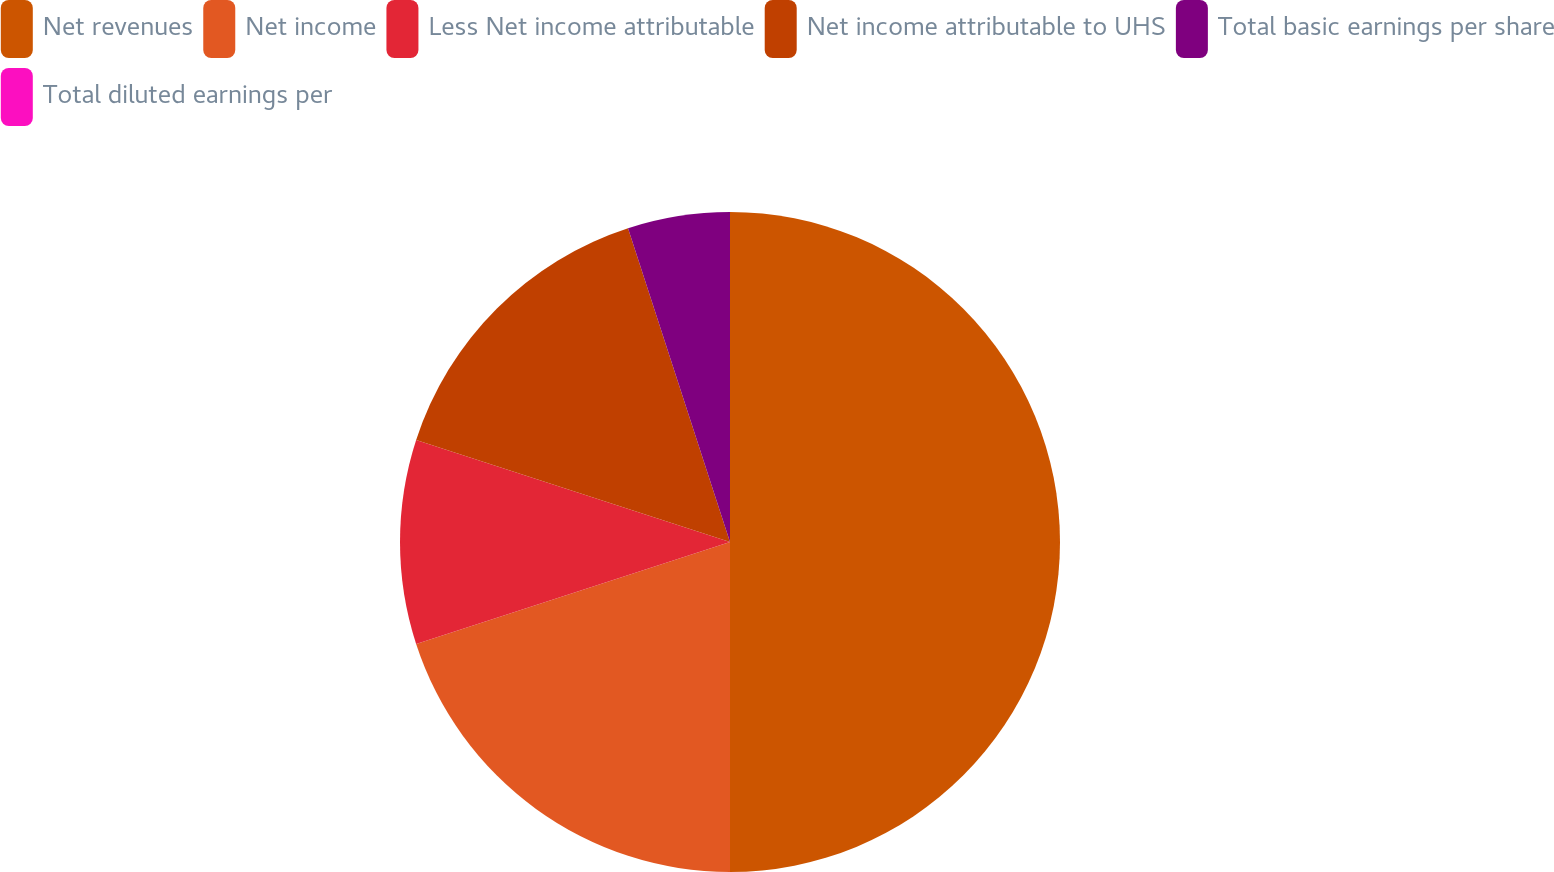<chart> <loc_0><loc_0><loc_500><loc_500><pie_chart><fcel>Net revenues<fcel>Net income<fcel>Less Net income attributable<fcel>Net income attributable to UHS<fcel>Total basic earnings per share<fcel>Total diluted earnings per<nl><fcel>50.0%<fcel>20.0%<fcel>10.0%<fcel>15.0%<fcel>5.0%<fcel>0.0%<nl></chart> 